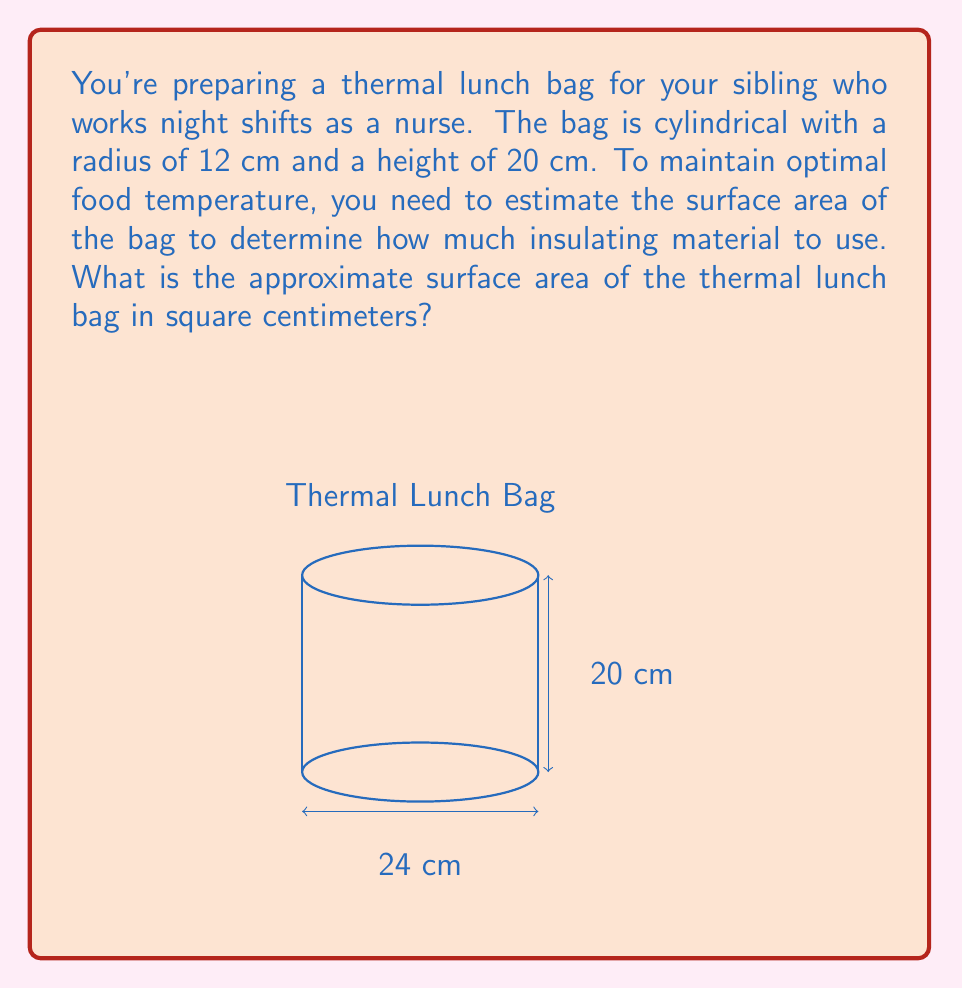Show me your answer to this math problem. To estimate the surface area of a cylindrical thermal lunch bag, we need to calculate the area of its circular top and bottom, plus the area of its curved side surface. Let's break it down step-by-step:

1. Given dimensions:
   Radius (r) = 12 cm
   Height (h) = 20 cm

2. Calculate the area of one circular base:
   $$A_{base} = \pi r^2 = \pi (12\,\text{cm})^2 = 144\pi\,\text{cm}^2$$

3. Calculate the area of the curved side surface:
   $$A_{side} = 2\pi rh = 2\pi (12\,\text{cm})(20\,\text{cm}) = 480\pi\,\text{cm}^2$$

4. Total surface area:
   $$\begin{align}
   A_{total} &= 2A_{base} + A_{side} \\
   &= 2(144\pi\,\text{cm}^2) + 480\pi\,\text{cm}^2 \\
   &= 288\pi\,\text{cm}^2 + 480\pi\,\text{cm}^2 \\
   &= 768\pi\,\text{cm}^2
   \end{align}$$

5. Approximate the result (π ≈ 3.14159):
   $$A_{total} \approx 768 \times 3.14159 \approx 2412.74\,\text{cm}^2$$

6. Round to the nearest whole number:
   $$A_{total} \approx 2413\,\text{cm}^2$$
Answer: 2413 cm² 